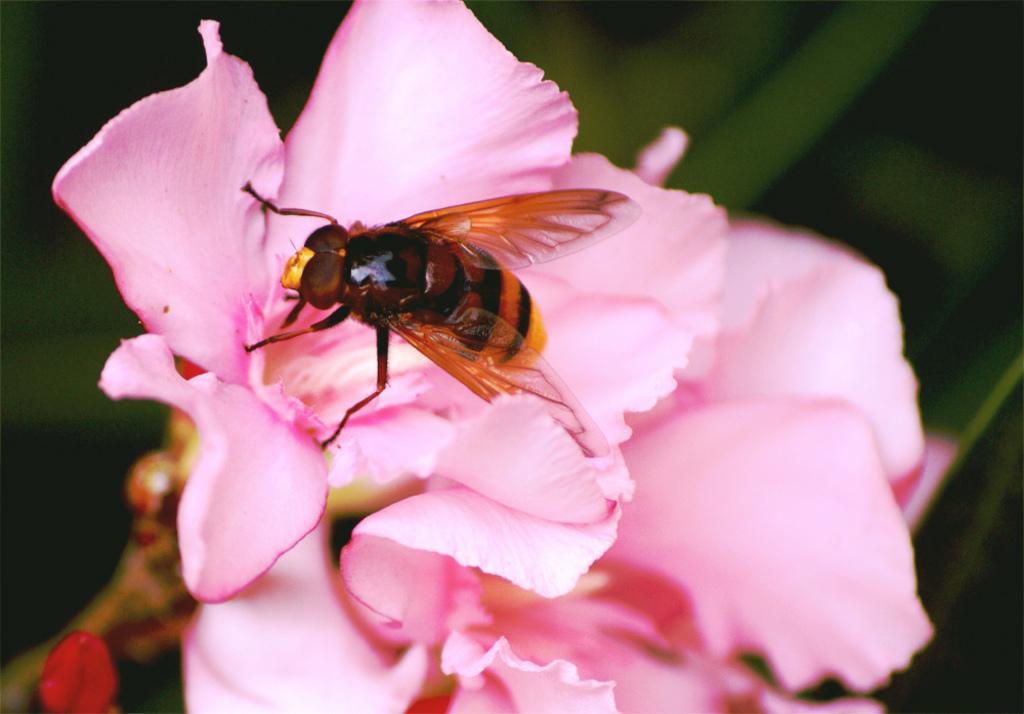Could you give a brief overview of what you see in this image? In this picture there are flowers in the center of the image and there is an insect on it. 